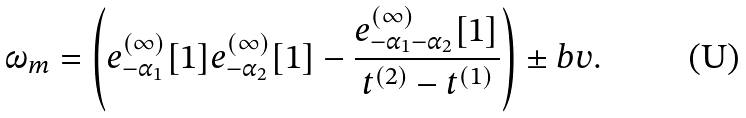<formula> <loc_0><loc_0><loc_500><loc_500>\omega _ { m } = \left ( e ^ { ( \infty ) } _ { - \alpha _ { 1 } } [ 1 ] e ^ { ( \infty ) } _ { - \alpha _ { 2 } } [ 1 ] - \frac { e ^ { ( \infty ) } _ { - \alpha _ { 1 } - \alpha _ { 2 } } [ 1 ] } { t ^ { ( 2 ) } - t ^ { ( 1 ) } } \right ) \pm b { v } .</formula> 